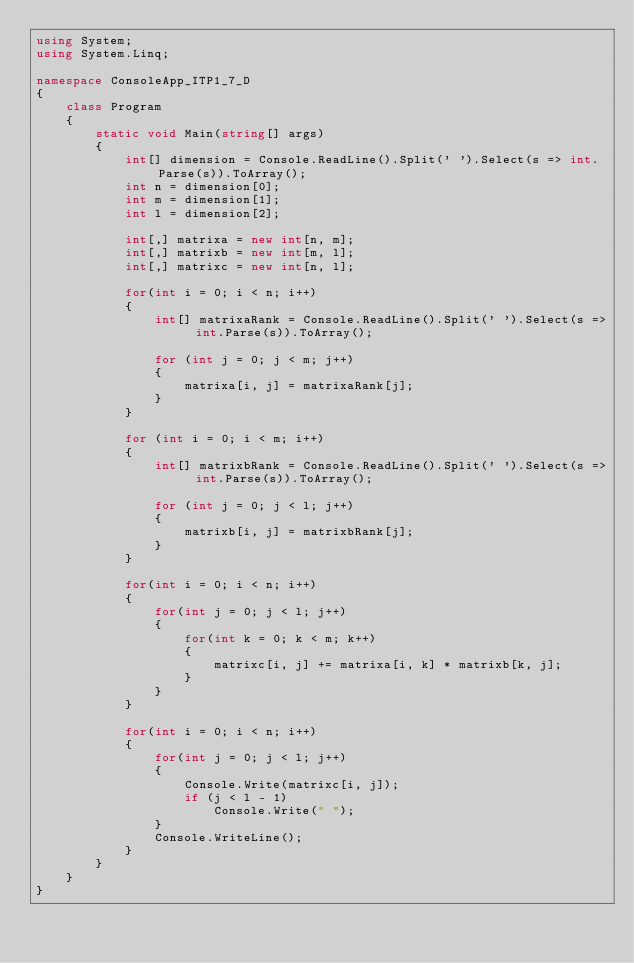<code> <loc_0><loc_0><loc_500><loc_500><_C#_>using System;
using System.Linq;

namespace ConsoleApp_ITP1_7_D
{
    class Program
    {
        static void Main(string[] args)
        {
            int[] dimension = Console.ReadLine().Split(' ').Select(s => int.Parse(s)).ToArray();
            int n = dimension[0];
            int m = dimension[1];
            int l = dimension[2];

            int[,] matrixa = new int[n, m];
            int[,] matrixb = new int[m, l];
            int[,] matrixc = new int[n, l];

            for(int i = 0; i < n; i++)
            {
                int[] matrixaRank = Console.ReadLine().Split(' ').Select(s => int.Parse(s)).ToArray();

                for (int j = 0; j < m; j++)
                {
                    matrixa[i, j] = matrixaRank[j];
                }
            }

            for (int i = 0; i < m; i++)
            {
                int[] matrixbRank = Console.ReadLine().Split(' ').Select(s => int.Parse(s)).ToArray();

                for (int j = 0; j < l; j++)
                {
                    matrixb[i, j] = matrixbRank[j];
                }
            }

            for(int i = 0; i < n; i++)
            {
                for(int j = 0; j < l; j++)
                {
                    for(int k = 0; k < m; k++)
                    {
                        matrixc[i, j] += matrixa[i, k] * matrixb[k, j];
                    }
                }
            }

            for(int i = 0; i < n; i++)
            {
                for(int j = 0; j < l; j++)
                {
                    Console.Write(matrixc[i, j]);
                    if (j < l - 1)
                        Console.Write(" ");
                }
                Console.WriteLine();
            }
        }
    }
}

</code> 